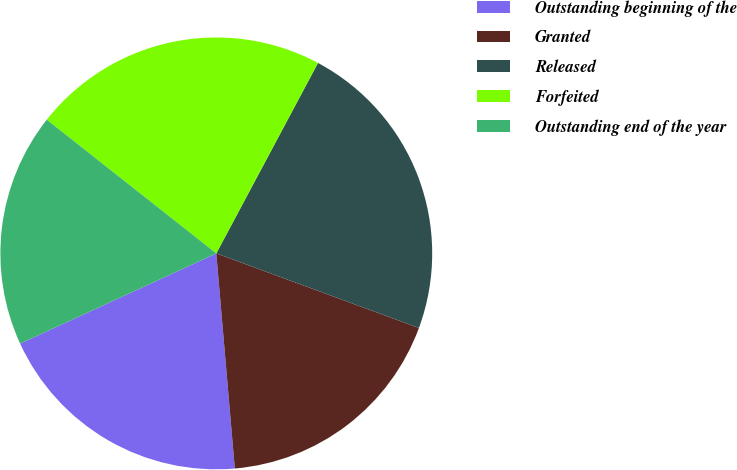<chart> <loc_0><loc_0><loc_500><loc_500><pie_chart><fcel>Outstanding beginning of the<fcel>Granted<fcel>Released<fcel>Forfeited<fcel>Outstanding end of the year<nl><fcel>19.51%<fcel>18.02%<fcel>22.81%<fcel>22.18%<fcel>17.49%<nl></chart> 